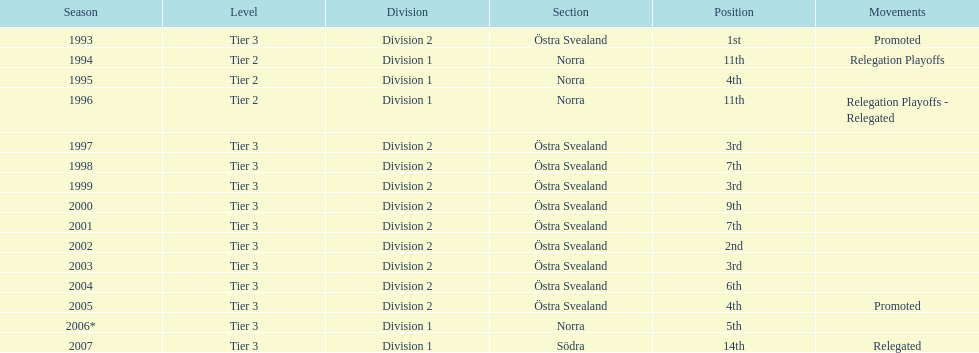What section did they play in the most? Östra Svealand. 